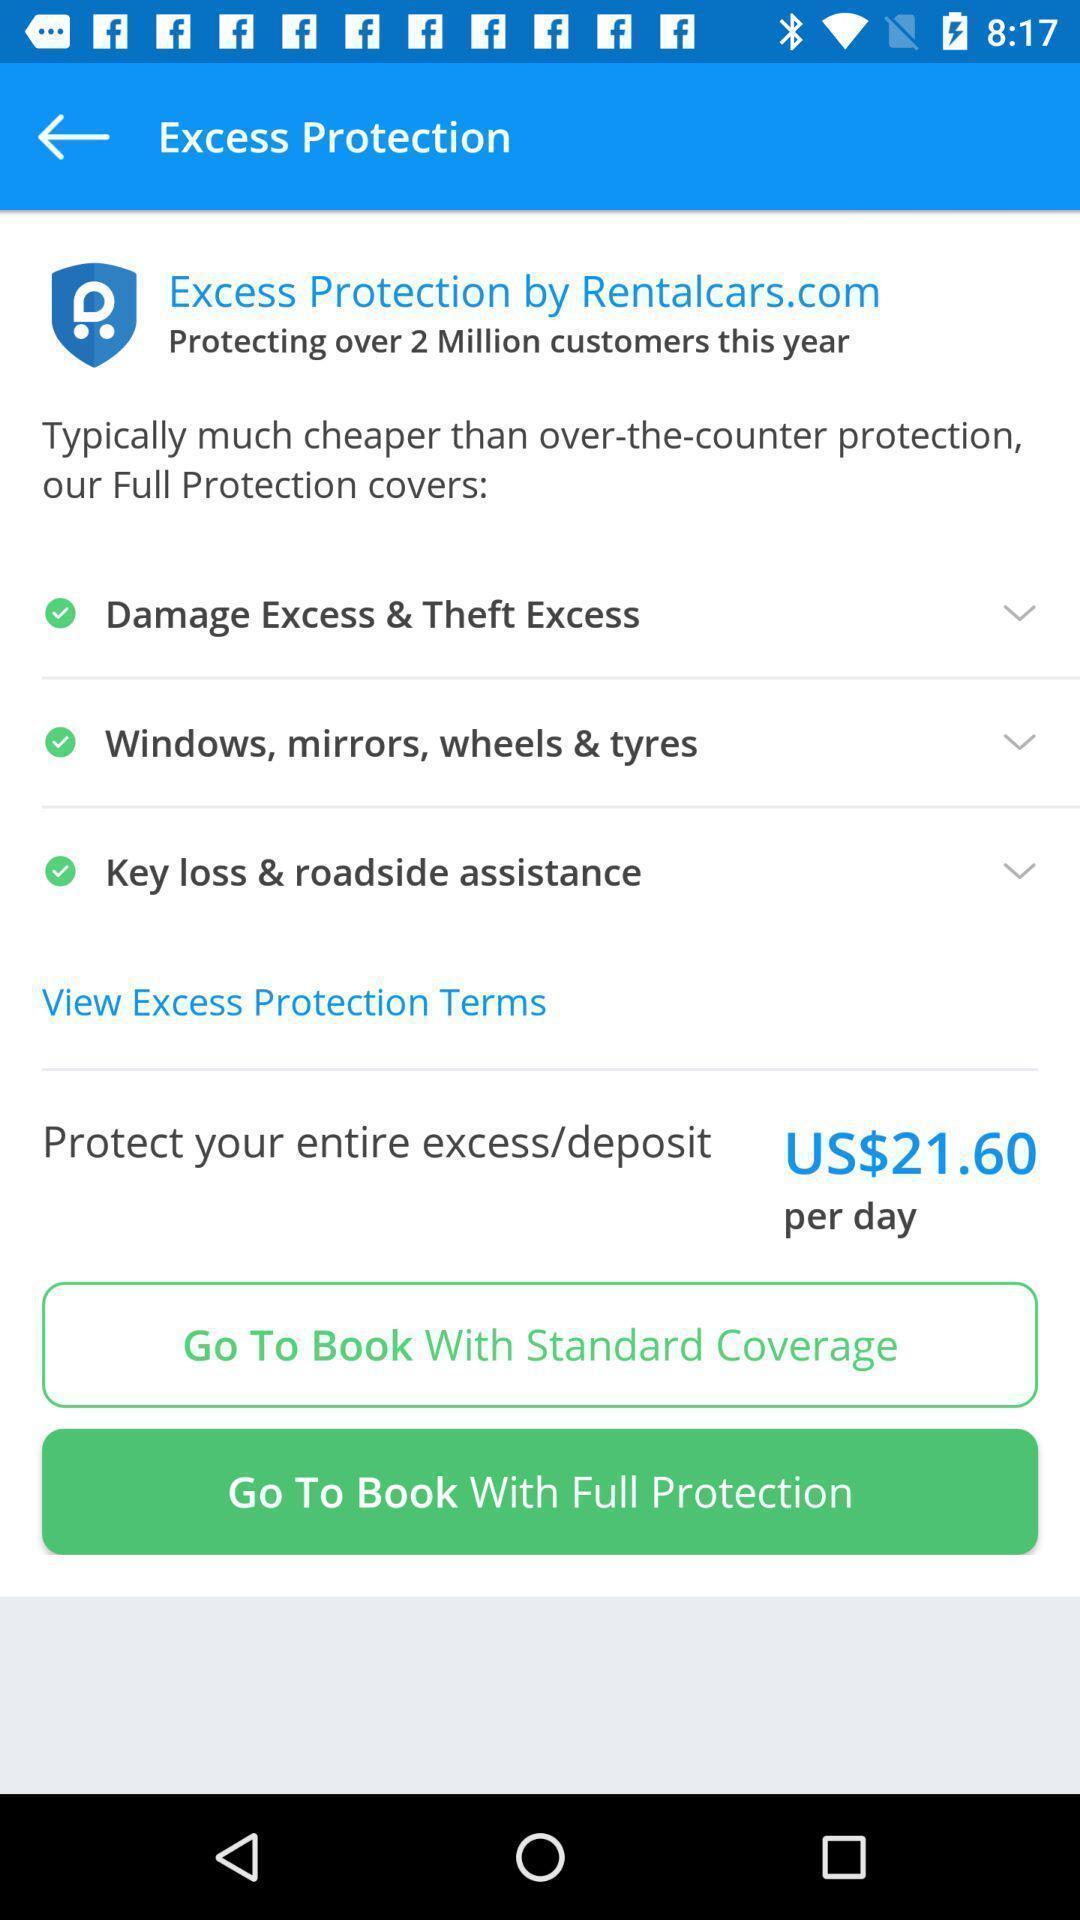Describe the content in this image. Page showing insurance options in a car rental app. 